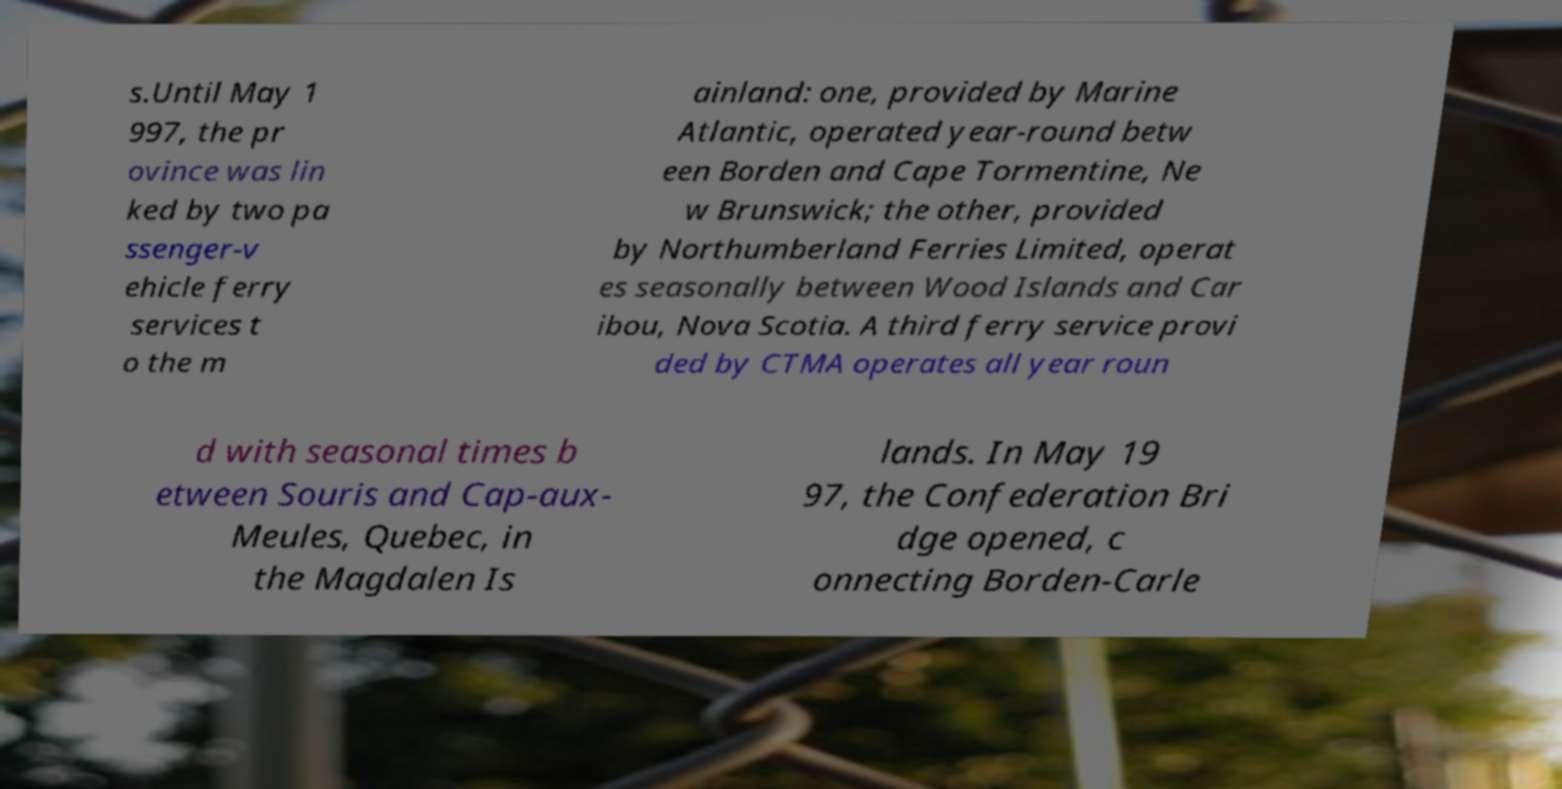Could you extract and type out the text from this image? s.Until May 1 997, the pr ovince was lin ked by two pa ssenger-v ehicle ferry services t o the m ainland: one, provided by Marine Atlantic, operated year-round betw een Borden and Cape Tormentine, Ne w Brunswick; the other, provided by Northumberland Ferries Limited, operat es seasonally between Wood Islands and Car ibou, Nova Scotia. A third ferry service provi ded by CTMA operates all year roun d with seasonal times b etween Souris and Cap-aux- Meules, Quebec, in the Magdalen Is lands. In May 19 97, the Confederation Bri dge opened, c onnecting Borden-Carle 